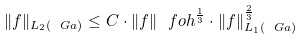<formula> <loc_0><loc_0><loc_500><loc_500>\| f \| _ { L _ { 2 } ( \ G a ) } \leq C \cdot \| f \| _ { \ } f o h ^ { \frac { 1 } { 3 } } \cdot \| f \| _ { L _ { 1 } ( \ G a ) } ^ { \frac { 2 } { 3 } }</formula> 